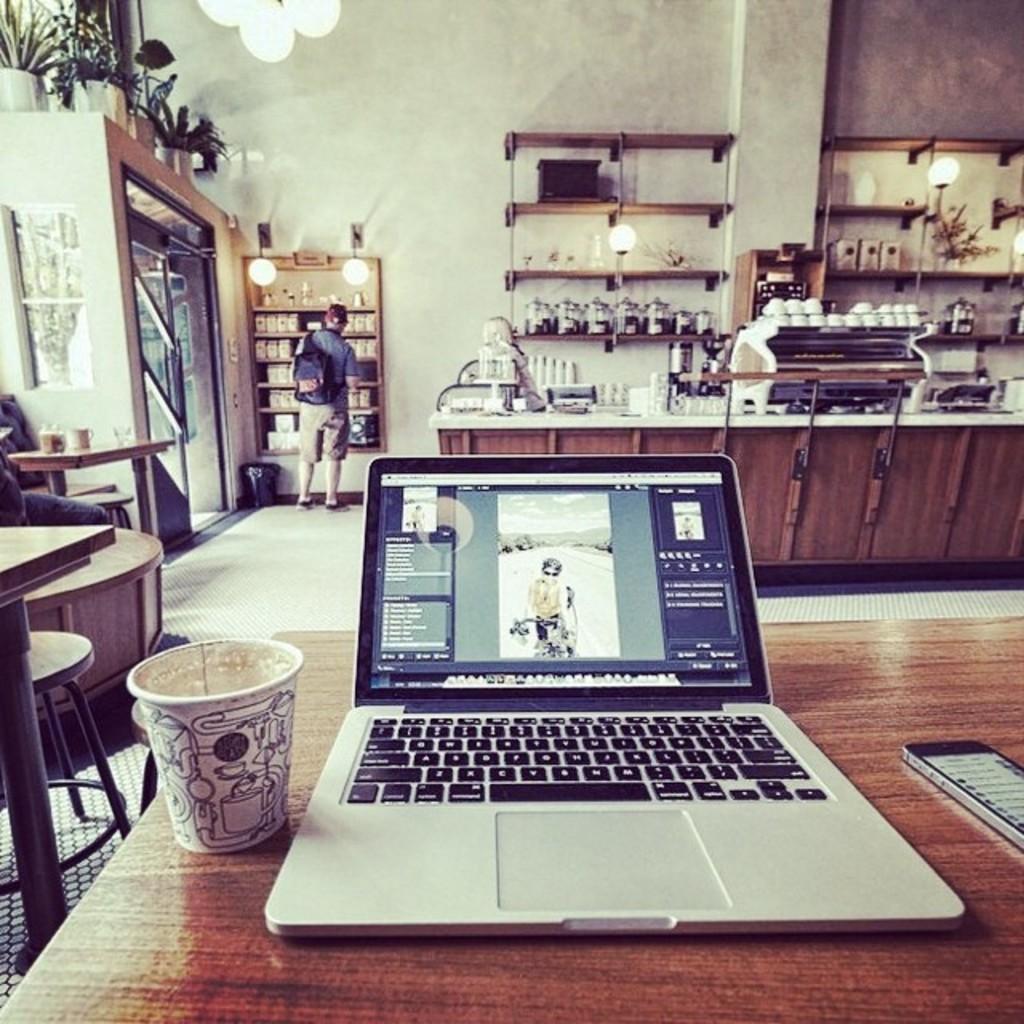Can you describe this image briefly? In this picture we can see laptop and aside to that glass and another side mobile placed on a table and in background we can see man carrying bag standing in front of the racks and we have flower pots with plants, wall, light, table full of some items, stool. 